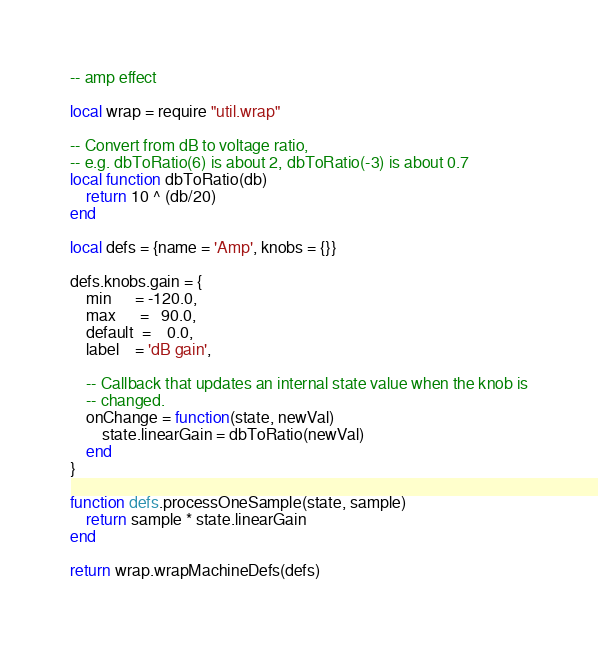Convert code to text. <code><loc_0><loc_0><loc_500><loc_500><_Lua_>-- amp effect

local wrap = require "util.wrap"

-- Convert from dB to voltage ratio,
-- e.g. dbToRatio(6) is about 2, dbToRatio(-3) is about 0.7
local function dbToRatio(db)
    return 10 ^ (db/20)
end

local defs = {name = 'Amp', knobs = {}}

defs.knobs.gain = {
    min      = -120.0,
    max      =   90.0,
    default  =    0.0,
    label    = 'dB gain',

    -- Callback that updates an internal state value when the knob is
    -- changed.
    onChange = function(state, newVal)
        state.linearGain = dbToRatio(newVal)
    end
}

function defs.processOneSample(state, sample)
    return sample * state.linearGain
end

return wrap.wrapMachineDefs(defs)
</code> 